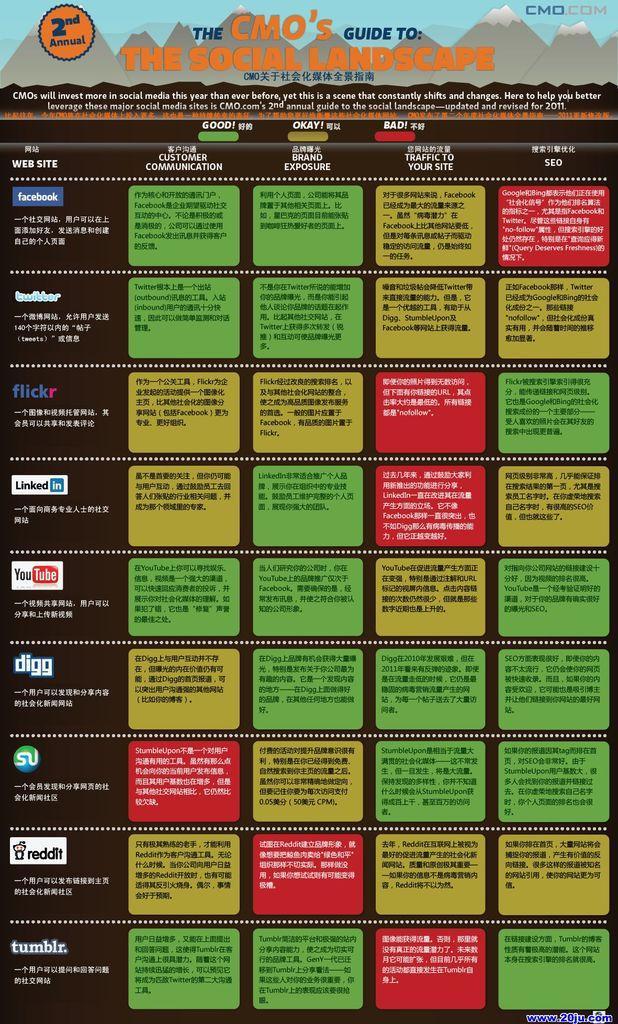Can you describe this image briefly? In this image there is a poster having some text. There are few app icons at the left side of the image. Top of the image there are few images of the hills having some text on it. 